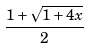<formula> <loc_0><loc_0><loc_500><loc_500>\frac { 1 + \sqrt { 1 + 4 x } } { 2 }</formula> 